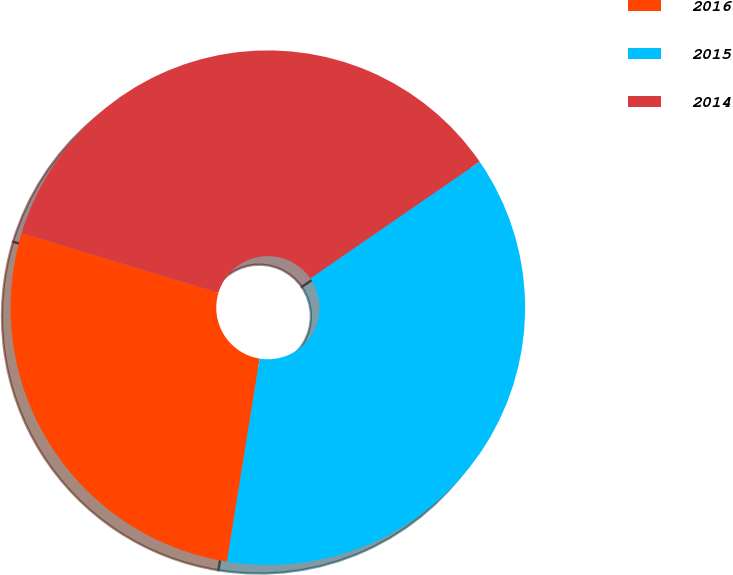Convert chart. <chart><loc_0><loc_0><loc_500><loc_500><pie_chart><fcel>2016<fcel>2015<fcel>2014<nl><fcel>27.14%<fcel>37.14%<fcel>35.71%<nl></chart> 